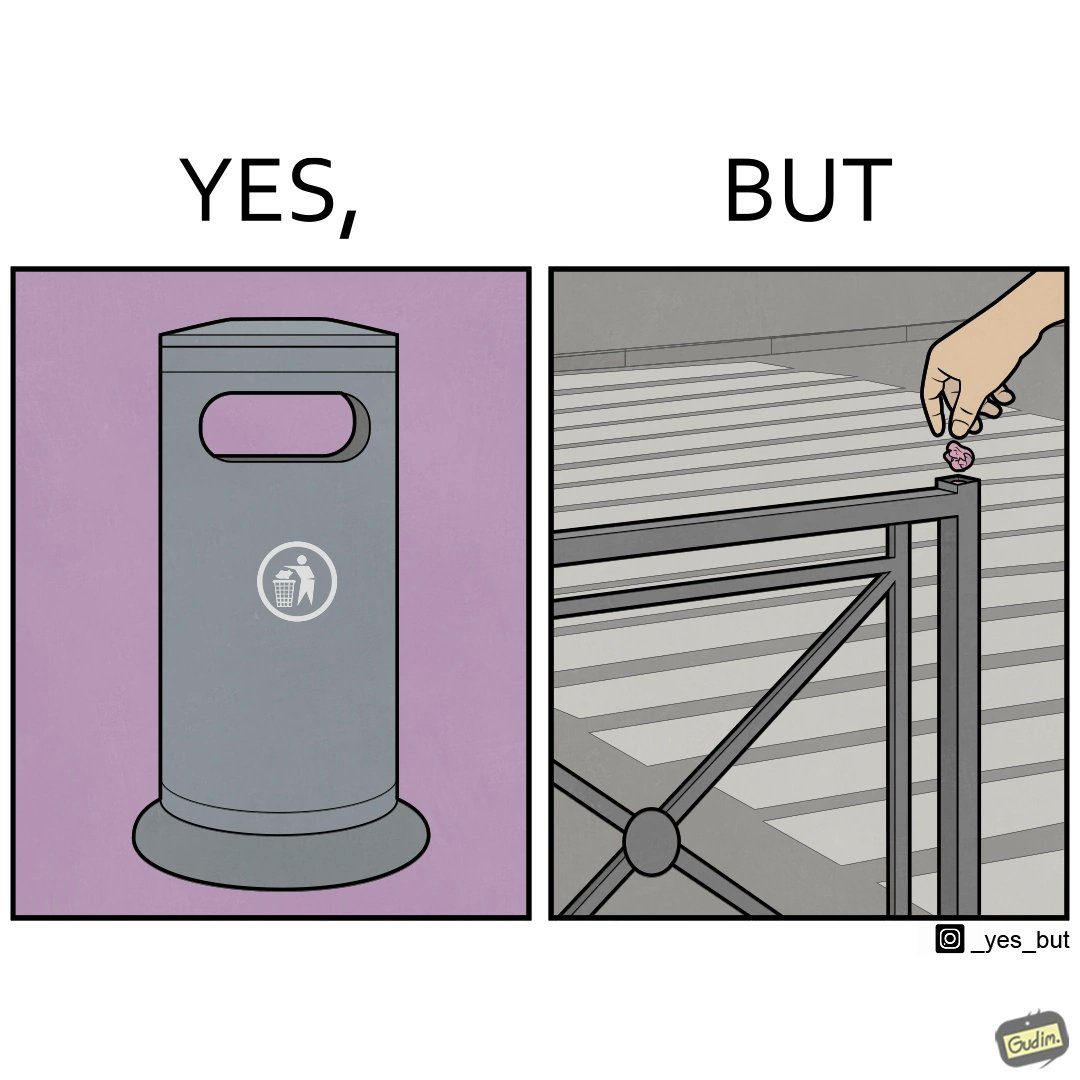What makes this image funny or satirical? The images are ironic because even though garbage bins are provided for humans to dispose waste, by habit humans still choose to make surroundings dirty by disposing garbage improperly 